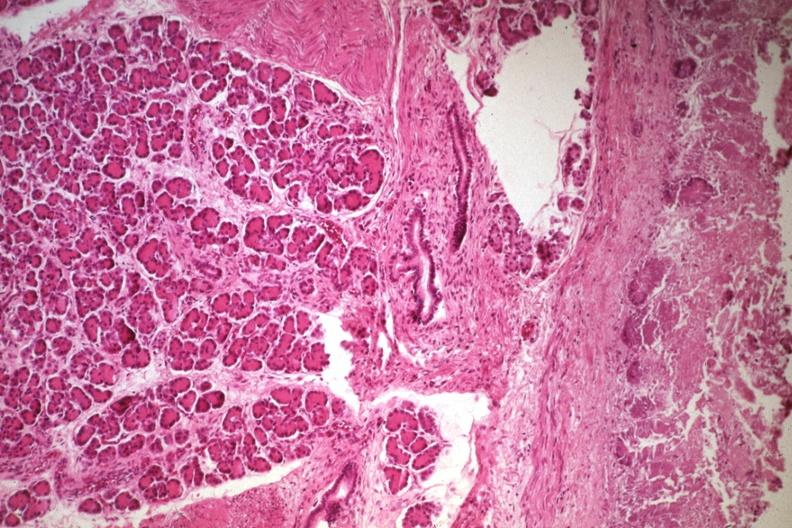s ectopic pancreas present?
Answer the question using a single word or phrase. Yes 